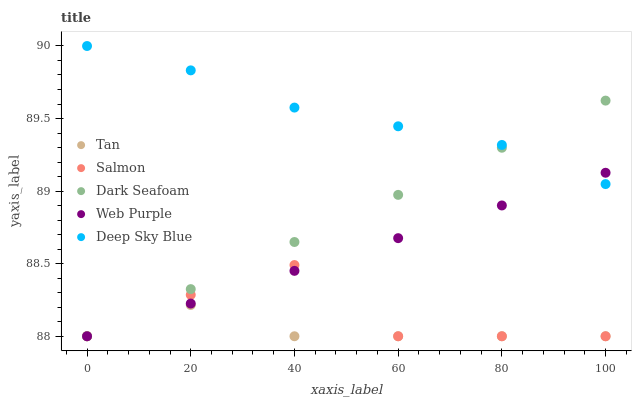Does Tan have the minimum area under the curve?
Answer yes or no. Yes. Does Deep Sky Blue have the maximum area under the curve?
Answer yes or no. Yes. Does Salmon have the minimum area under the curve?
Answer yes or no. No. Does Salmon have the maximum area under the curve?
Answer yes or no. No. Is Web Purple the smoothest?
Answer yes or no. Yes. Is Salmon the roughest?
Answer yes or no. Yes. Is Tan the smoothest?
Answer yes or no. No. Is Tan the roughest?
Answer yes or no. No. Does Web Purple have the lowest value?
Answer yes or no. Yes. Does Deep Sky Blue have the lowest value?
Answer yes or no. No. Does Deep Sky Blue have the highest value?
Answer yes or no. Yes. Does Salmon have the highest value?
Answer yes or no. No. Is Tan less than Deep Sky Blue?
Answer yes or no. Yes. Is Deep Sky Blue greater than Tan?
Answer yes or no. Yes. Does Deep Sky Blue intersect Web Purple?
Answer yes or no. Yes. Is Deep Sky Blue less than Web Purple?
Answer yes or no. No. Is Deep Sky Blue greater than Web Purple?
Answer yes or no. No. Does Tan intersect Deep Sky Blue?
Answer yes or no. No. 